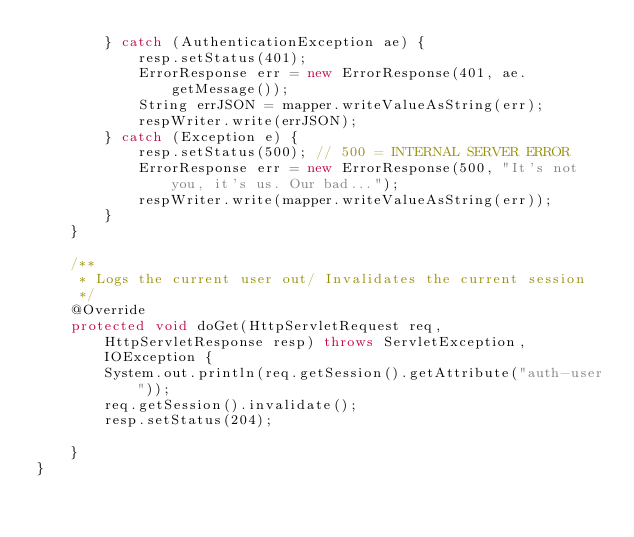<code> <loc_0><loc_0><loc_500><loc_500><_Java_>        } catch (AuthenticationException ae) {
            resp.setStatus(401);
            ErrorResponse err = new ErrorResponse(401, ae.getMessage());
            String errJSON = mapper.writeValueAsString(err);
            respWriter.write(errJSON);
        } catch (Exception e) {
            resp.setStatus(500); // 500 = INTERNAL SERVER ERROR
            ErrorResponse err = new ErrorResponse(500, "It's not you, it's us. Our bad...");
            respWriter.write(mapper.writeValueAsString(err));
        }
    }

    /**
     * Logs the current user out/ Invalidates the current session
     */
    @Override
    protected void doGet(HttpServletRequest req, HttpServletResponse resp) throws ServletException, IOException {
        System.out.println(req.getSession().getAttribute("auth-user"));
        req.getSession().invalidate();
        resp.setStatus(204);

    }
}
</code> 